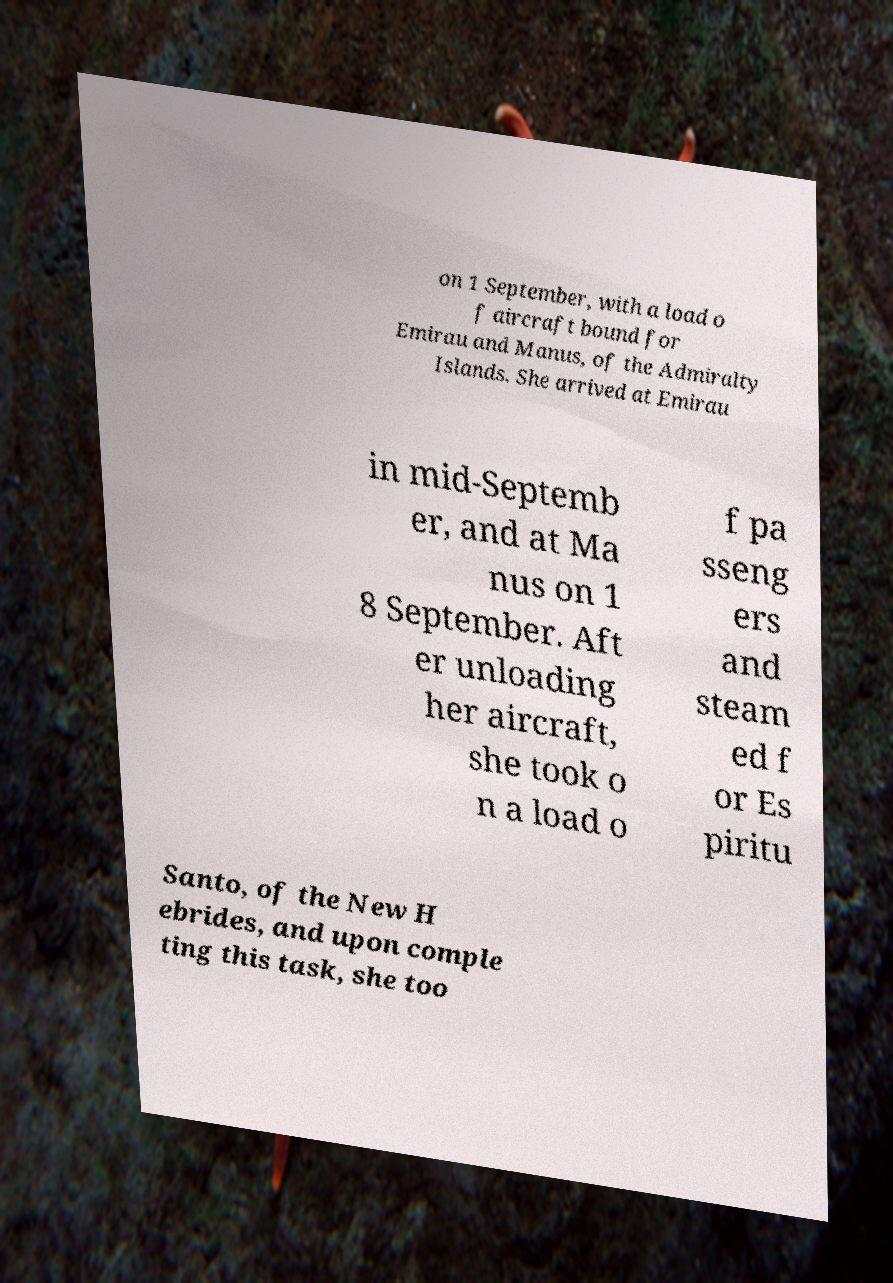I need the written content from this picture converted into text. Can you do that? on 1 September, with a load o f aircraft bound for Emirau and Manus, of the Admiralty Islands. She arrived at Emirau in mid-Septemb er, and at Ma nus on 1 8 September. Aft er unloading her aircraft, she took o n a load o f pa sseng ers and steam ed f or Es piritu Santo, of the New H ebrides, and upon comple ting this task, she too 